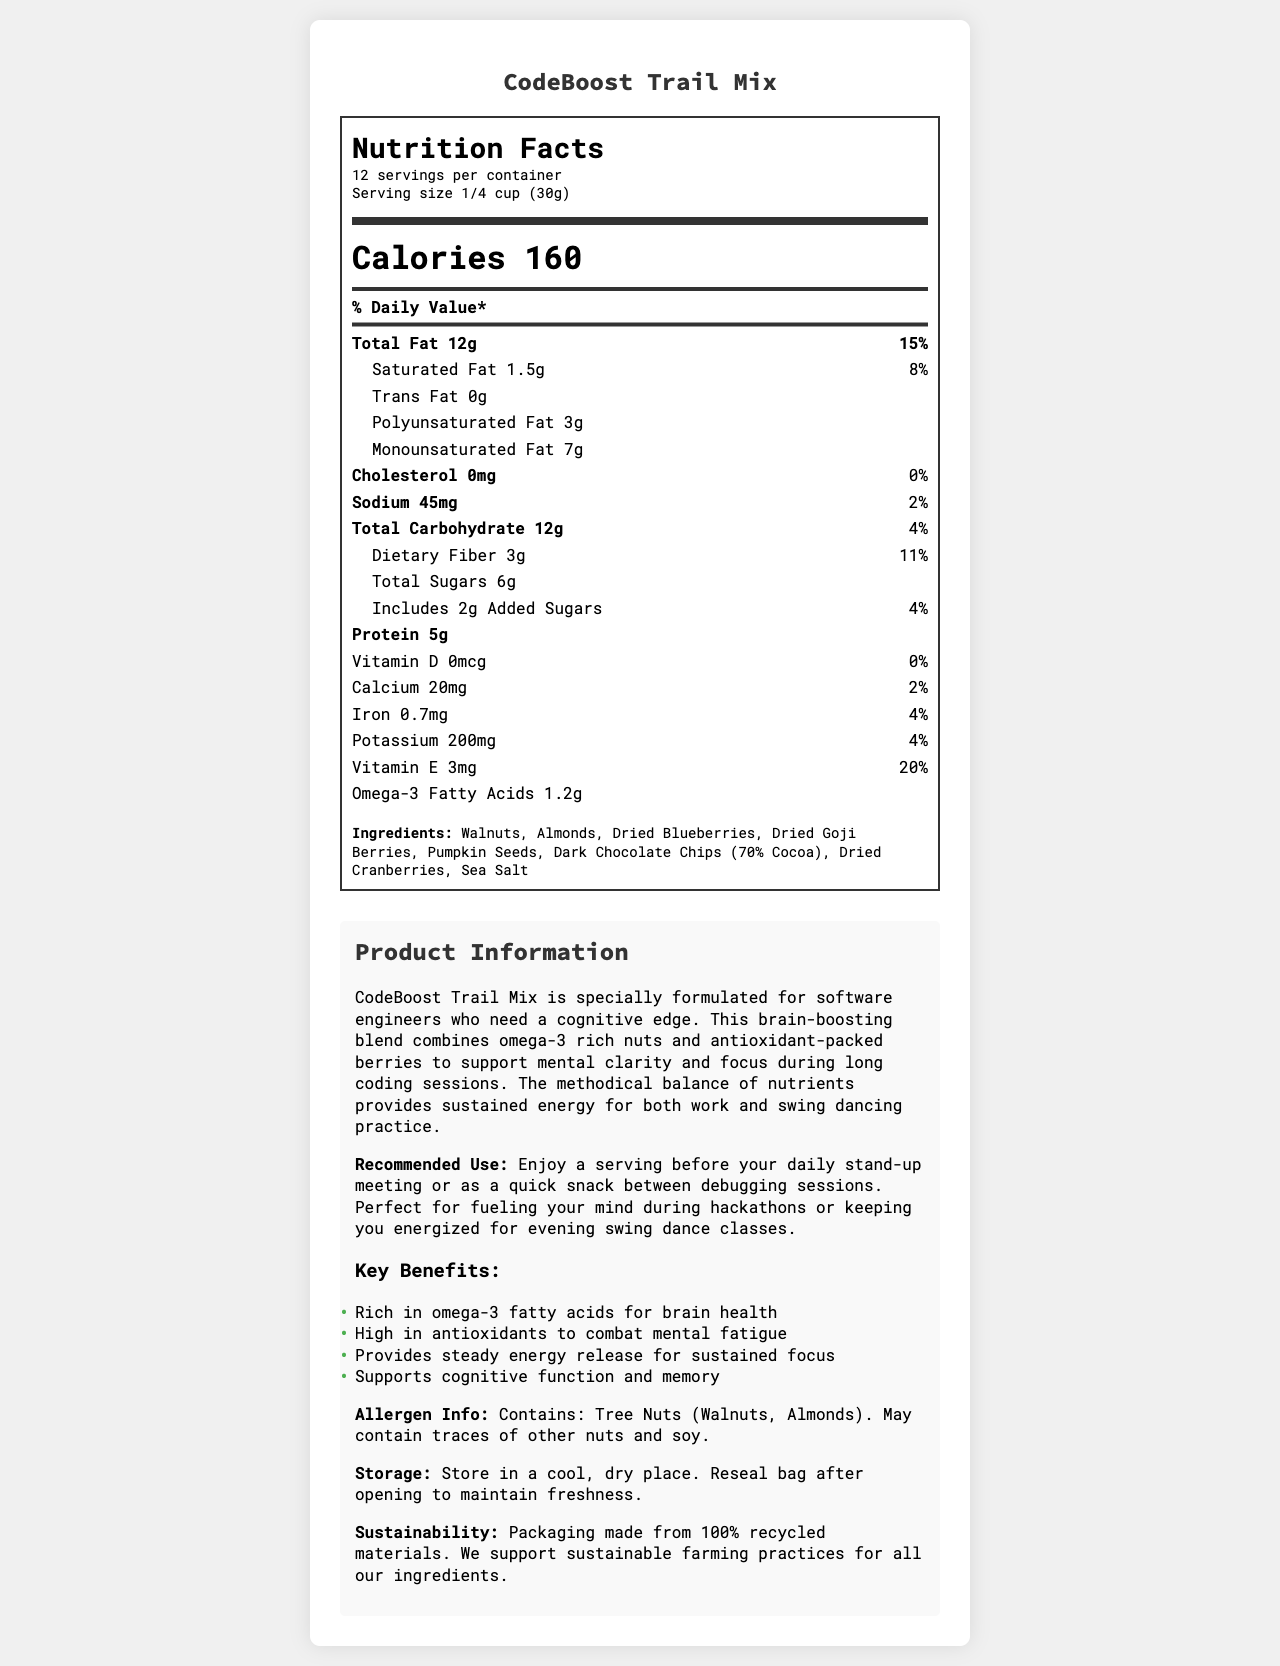what is the serving size of the CodeBoost Trail Mix? The serving size is mentioned in the serving information section under the nutrition facts.
Answer: 1/4 cup (30g) how many calories are there per serving? The calorie content per serving is listed as 160 in the nutrition facts section.
Answer: 160 calories what are the ingredients of the CodeBoost Trail Mix? The ingredients are listed in the ingredients section of the nutrition label.
Answer: Walnuts, Almonds, Dried Blueberries, Dried Goji Berries, Pumpkin Seeds, Dark Chocolate Chips (70% Cocoa), Dried Cranberries, Sea Salt what is the percentage of daily value for saturated fat? The percentage of daily value for saturated fat is found under the saturated fat listing in the nutrition facts.
Answer: 8% how much dietary fiber is in each serving? The amount of dietary fiber per serving is listed as 3g in the nutrition facts.
Answer: 3g how should the CodeBoost Trail Mix be stored? The storage instructions are mentioned in the product information section.
Answer: Store in a cool, dry place. Reseal bag after opening to maintain freshness. does CodeBoost Trail Mix contain any allergens? The allergen information is clearly stated in the product information section.
Answer: Yes, it contains tree nuts (walnuts, almonds). May contain traces of other nuts and soy. which of the following is NOT a key benefit listed for CodeBoost Trail Mix? A. Rich in omega-3 fatty acids B. High in antioxidants C. Low in calories D. Provides steady energy release The document lists benefits including being rich in omega-3 fatty acids, high in antioxidants, and providing steady energy release. It does not mention low calories as a benefit.
Answer: C how much omega-3 fatty acids does each serving contain? The amount of omega-3 fatty acids per serving is listed as 1.2g in the nutrition facts.
Answer: 1.2g is there any vitamin D in CodeBoost Trail Mix? The vitamin D amount is listed as 0mcg with 0% daily value in the nutrition facts.
Answer: No how many servings are there per container? The servings per container is mentioned as 12 in the serving information section.
Answer: 12 which nutrient has the highest percentage of daily value? A. Total Fat B. Dietary Fiber C. Sodium D. Vitamin E Vitamin E has the highest daily value percentage at 20%, compared to total fat (15%), dietary fiber (11%), and sodium (2%).
Answer: D what is the daily value percentage for calcium? The daily value percentage for calcium is listed as 2% in the nutrition facts.
Answer: 2% can you find information about omega-6 fatty acids in the document? The document provides information on omega-3 fatty acids but does not mention omega-6 fatty acids.
Answer: No what is the main idea of this document? The document aims to give a comprehensive overview of CodeBoost Trail Mix, including its nutritional benefits, ingredients, usage recommendations, and special notes for storage and allergens.
Answer: The document provides detailed nutritional information, ingredient list, and product description for CodeBoost Trail Mix, highlighting its cognitive benefits for software engineers and swing dancers while also detailing storage, allergen information, and sustainability notes. what is the percentage of daily value for iron? The daily value percentage for iron is listed as 4% in the nutrition facts.
Answer: 4% 